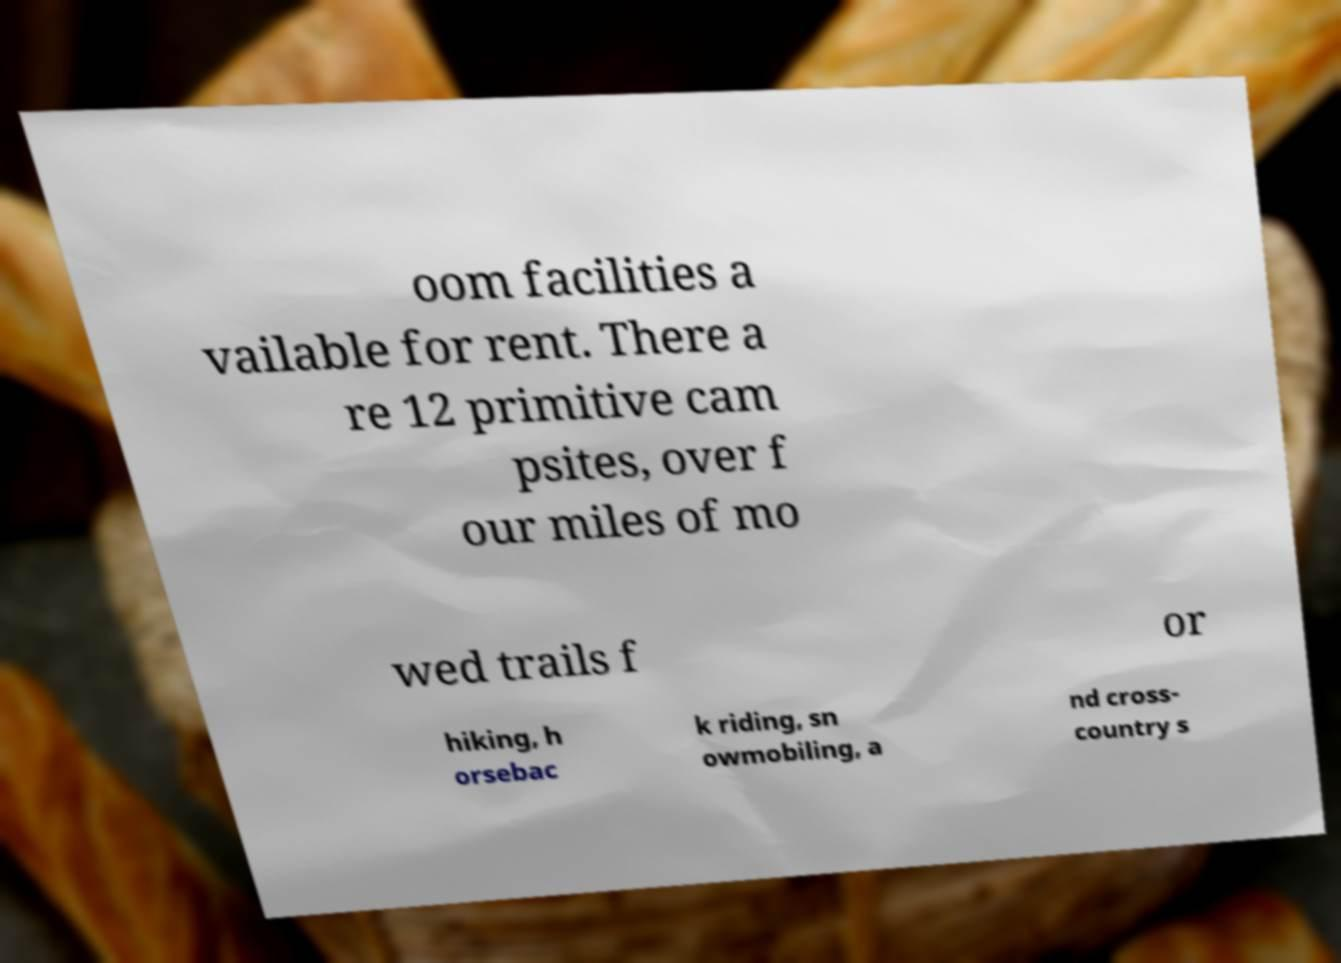Can you read and provide the text displayed in the image?This photo seems to have some interesting text. Can you extract and type it out for me? oom facilities a vailable for rent. There a re 12 primitive cam psites, over f our miles of mo wed trails f or hiking, h orsebac k riding, sn owmobiling, a nd cross- country s 